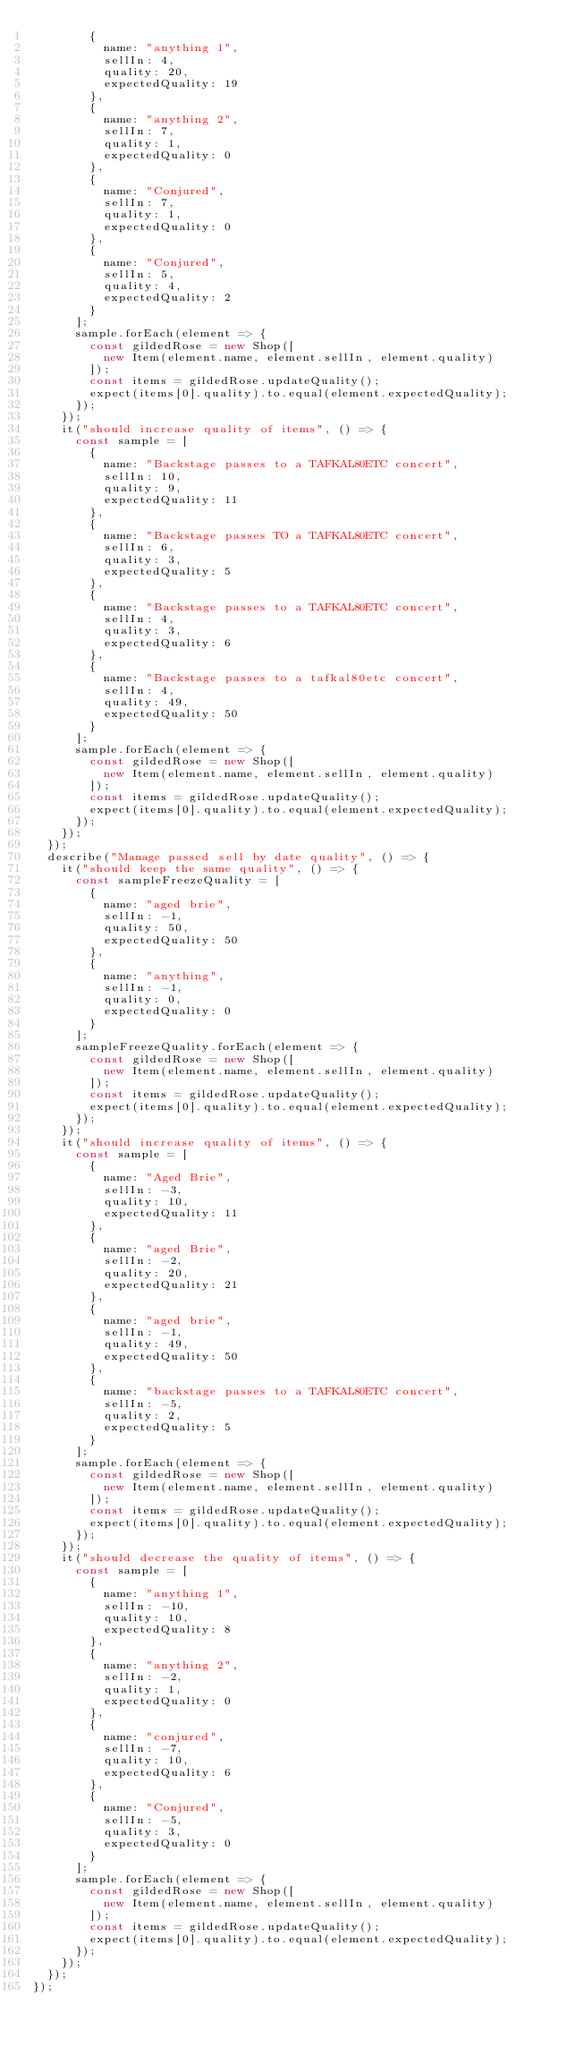<code> <loc_0><loc_0><loc_500><loc_500><_JavaScript_>        {
          name: "anything 1",
          sellIn: 4,
          quality: 20,
          expectedQuality: 19
        },
        {
          name: "anything 2",
          sellIn: 7,
          quality: 1,
          expectedQuality: 0
        },
        {
          name: "Conjured",
          sellIn: 7,
          quality: 1,
          expectedQuality: 0
        },
        {
          name: "Conjured",
          sellIn: 5,
          quality: 4,
          expectedQuality: 2
        }
      ];
      sample.forEach(element => {
        const gildedRose = new Shop([
          new Item(element.name, element.sellIn, element.quality)
        ]);
        const items = gildedRose.updateQuality();
        expect(items[0].quality).to.equal(element.expectedQuality);
      });
    });
    it("should increase quality of items", () => {
      const sample = [
        {
          name: "Backstage passes to a TAFKAL80ETC concert",
          sellIn: 10,
          quality: 9,
          expectedQuality: 11
        },
        {
          name: "Backstage passes TO a TAFKAL80ETC concert",
          sellIn: 6,
          quality: 3,
          expectedQuality: 5
        },
        {
          name: "Backstage passes to a TAFKAL80ETC concert",
          sellIn: 4,
          quality: 3,
          expectedQuality: 6
        },
        {
          name: "Backstage passes to a tafkal80etc concert",
          sellIn: 4,
          quality: 49,
          expectedQuality: 50
        }
      ];
      sample.forEach(element => {
        const gildedRose = new Shop([
          new Item(element.name, element.sellIn, element.quality)
        ]);
        const items = gildedRose.updateQuality();
        expect(items[0].quality).to.equal(element.expectedQuality);
      });
    });
  });
  describe("Manage passed sell by date quality", () => {
    it("should keep the same quality", () => {
      const sampleFreezeQuality = [
        {
          name: "aged brie",
          sellIn: -1,
          quality: 50,
          expectedQuality: 50
        },
        {
          name: "anything",
          sellIn: -1,
          quality: 0,
          expectedQuality: 0
        }
      ];
      sampleFreezeQuality.forEach(element => {
        const gildedRose = new Shop([
          new Item(element.name, element.sellIn, element.quality)
        ]);
        const items = gildedRose.updateQuality();
        expect(items[0].quality).to.equal(element.expectedQuality);
      });
    });
    it("should increase quality of items", () => {
      const sample = [
        {
          name: "Aged Brie",
          sellIn: -3,
          quality: 10,
          expectedQuality: 11
        },
        {
          name: "aged Brie",
          sellIn: -2,
          quality: 20,
          expectedQuality: 21
        },
        {
          name: "aged brie",
          sellIn: -1,
          quality: 49,
          expectedQuality: 50
        },
        {
          name: "backstage passes to a TAFKAL80ETC concert",
          sellIn: -5,
          quality: 2,
          expectedQuality: 5
        }
      ];
      sample.forEach(element => {
        const gildedRose = new Shop([
          new Item(element.name, element.sellIn, element.quality)
        ]);
        const items = gildedRose.updateQuality();
        expect(items[0].quality).to.equal(element.expectedQuality);
      });
    });
    it("should decrease the quality of items", () => {
      const sample = [
        {
          name: "anything 1",
          sellIn: -10,
          quality: 10,
          expectedQuality: 8
        },
        {
          name: "anything 2",
          sellIn: -2,
          quality: 1,
          expectedQuality: 0
        },
        {
          name: "conjured",
          sellIn: -7,
          quality: 10,
          expectedQuality: 6
        },
        {
          name: "Conjured",
          sellIn: -5,
          quality: 3,
          expectedQuality: 0
        }
      ];
      sample.forEach(element => {
        const gildedRose = new Shop([
          new Item(element.name, element.sellIn, element.quality)
        ]);
        const items = gildedRose.updateQuality();
        expect(items[0].quality).to.equal(element.expectedQuality);
      });
    });
  });
});
</code> 